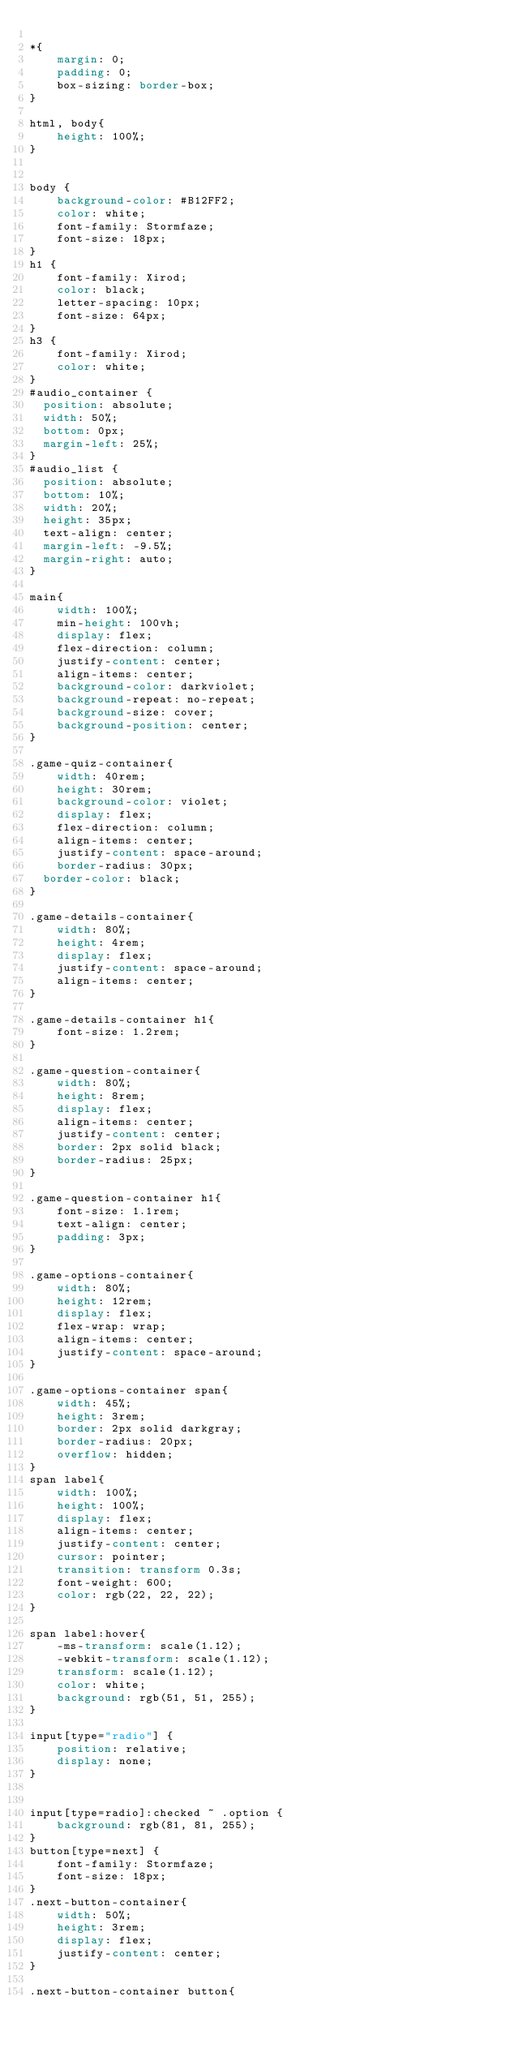<code> <loc_0><loc_0><loc_500><loc_500><_CSS_>
*{
    margin: 0;
    padding: 0;
    box-sizing: border-box;
}

html, body{
    height: 100%;
}


body {
    background-color: #B12FF2;
    color: white;
    font-family: Stormfaze;
    font-size: 18px;
}
h1 {
    font-family: Xirod;
    color: black;
    letter-spacing: 10px;
    font-size: 64px;
}
h3 {
    font-family: Xirod;
    color: white;
}
#audio_container {
	position: absolute;
	width: 50%;
	bottom: 0px;
	margin-left: 25%;
}
#audio_list {
	position: absolute;
	bottom: 10%;
	width: 20%;
	height: 35px;
	text-align: center;
	margin-left: -9.5%;
	margin-right: auto;
}

main{
    width: 100%;
    min-height: 100vh;
    display: flex;
    flex-direction: column;
    justify-content: center;
    align-items: center;
    background-color: darkviolet;
    background-repeat: no-repeat;
    background-size: cover;
    background-position: center;
}

.game-quiz-container{
    width: 40rem;
    height: 30rem;
    background-color: violet;
    display: flex;
    flex-direction: column;
    align-items: center;
    justify-content: space-around;
    border-radius: 30px;
	border-color: black;
}

.game-details-container{
    width: 80%;
    height: 4rem;
    display: flex;
    justify-content: space-around;
    align-items: center;
}

.game-details-container h1{
    font-size: 1.2rem;
}

.game-question-container{
    width: 80%;
    height: 8rem;
    display: flex;
    align-items: center;
    justify-content: center;
    border: 2px solid black;
    border-radius: 25px;
}

.game-question-container h1{
    font-size: 1.1rem;
    text-align: center;
    padding: 3px;
}

.game-options-container{
    width: 80%;
    height: 12rem;
    display: flex;
    flex-wrap: wrap;
    align-items: center;
    justify-content: space-around;
}

.game-options-container span{
    width: 45%;
    height: 3rem;
    border: 2px solid darkgray;
    border-radius: 20px;
    overflow: hidden;
}
span label{
    width: 100%;
    height: 100%;
    display: flex;
    align-items: center;
    justify-content: center;
    cursor: pointer;
    transition: transform 0.3s;
    font-weight: 600;
    color: rgb(22, 22, 22);
}

span label:hover{
    -ms-transform: scale(1.12);
    -webkit-transform: scale(1.12);
    transform: scale(1.12);
    color: white;
    background: rgb(51, 51, 255);
}

input[type="radio"] {
    position: relative;
    display: none;
}


input[type=radio]:checked ~ .option {
    background: rgb(81, 81, 255);
}
button[type=next] {
    font-family: Stormfaze;
    font-size: 18px;
}
.next-button-container{
    width: 50%;
    height: 3rem;
    display: flex;
    justify-content: center;
}

.next-button-container button{</code> 